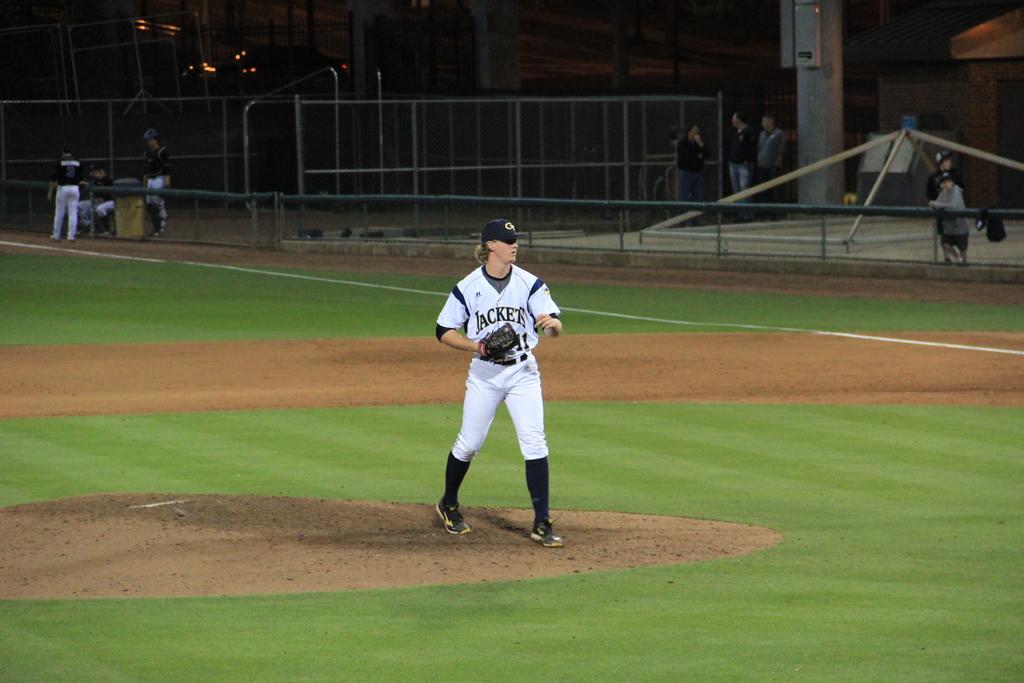What team does the pitcher suit up for?
Provide a short and direct response. Jackets. What number is he?
Ensure brevity in your answer.  11. 